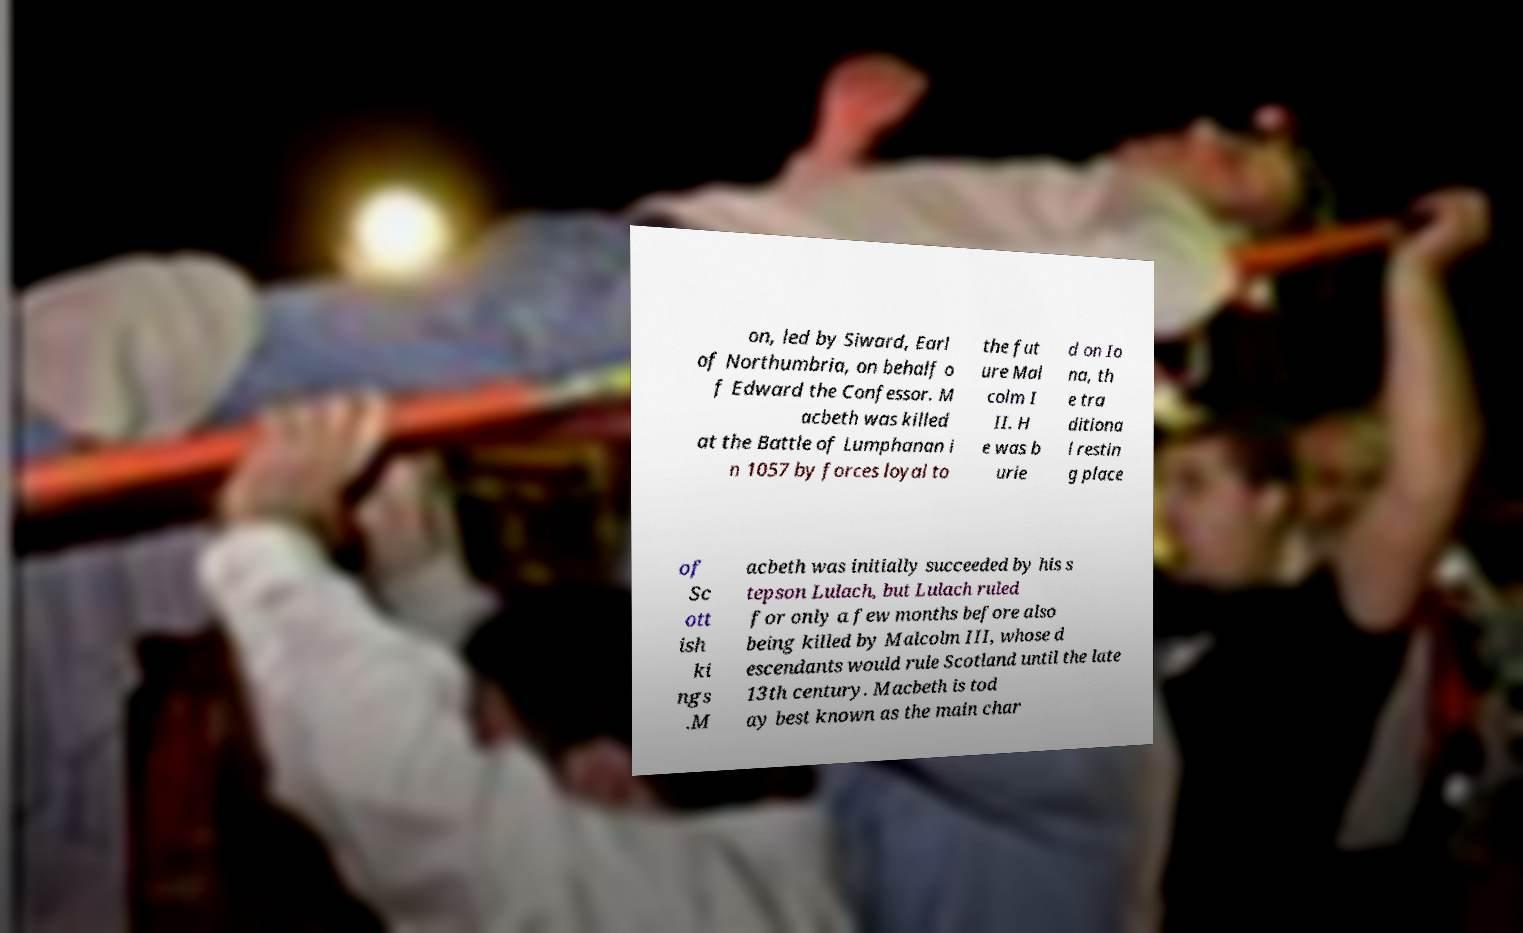Please identify and transcribe the text found in this image. on, led by Siward, Earl of Northumbria, on behalf o f Edward the Confessor. M acbeth was killed at the Battle of Lumphanan i n 1057 by forces loyal to the fut ure Mal colm I II. H e was b urie d on Io na, th e tra ditiona l restin g place of Sc ott ish ki ngs .M acbeth was initially succeeded by his s tepson Lulach, but Lulach ruled for only a few months before also being killed by Malcolm III, whose d escendants would rule Scotland until the late 13th century. Macbeth is tod ay best known as the main char 